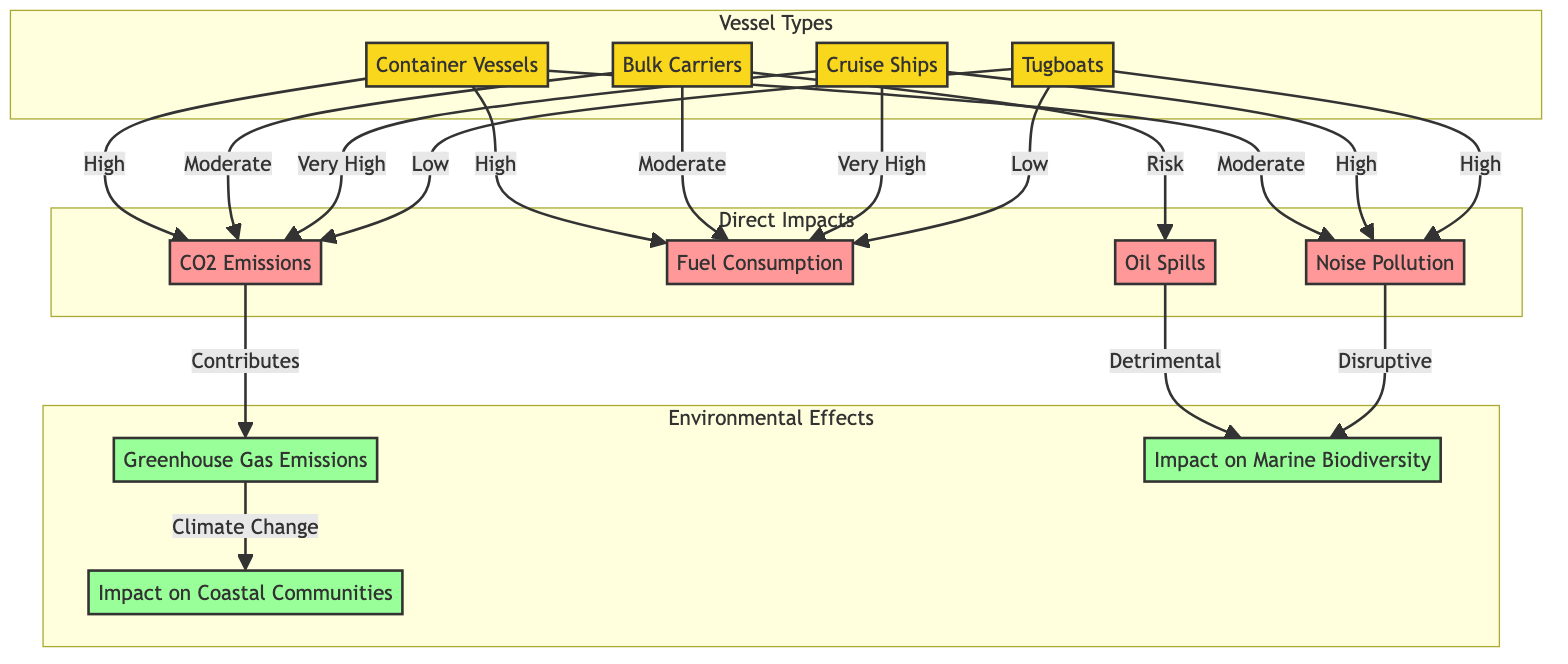What's the impact of container vessels on CO2 emissions? The diagram states that container vessels have a "High" impact on CO2 emissions, as indicated by the direct connection from the container vessels node to the CO2 emissions node with the label "High".
Answer: High How many types of vessels are shown in the diagram? The diagram includes a subgraph labeled "Vessel Types" that lists four types of vessels: container vessels, bulk carriers, cruise ships, and tugboats. Thus, the total number is four.
Answer: 4 Which vessel type has the highest level of fuel consumption? The diagram indicates that cruise ships have a "Very High" level of fuel consumption, as shown by the connection from cruise ships to the fuel consumption node with the label "Very High".
Answer: Very High What type of pollution do bulk carriers pose a risk for? The diagram shows that bulk carriers have a "Risk" associated with oil spills, as indicated by the connection from bulk carriers to the oil spills node labeled "Risk".
Answer: Oil Spills Which environmental effect is primarily affected by CO2 emissions? According to the diagram, CO2 emissions contribute to greenhouse gas emissions, as illustrated by the direct connection from the CO2 emissions node to the greenhouse gas node labeled "Contributes".
Answer: Greenhouse Gas Emissions What is the level of noise pollution caused by tugboats? The diagram states that tugboats have a "High" impact on noise pollution, as indicated by the connection from the tugboats node to the noise pollution node with the label "High".
Answer: High Which type of vessel primarily impacts marine biodiversity? The diagram indicates that both oil spills and noise pollution are detrimental and disruptive to marine biodiversity, but neither of these directly points to a specific vessel type. However, since bulk carriers pose a risk of oil spills, a strong connection can be inferred.
Answer: Bulk Carriers How does greenhouse gas emissions impact coastal communities? The diagram shows a direct connection from greenhouse gas emissions to the impact on coastal communities node with the label "Climate Change", suggesting that greenhouse gas emissions contribute adversely to community impact.
Answer: Climate Change What is the relationship between noise pollution and marine biodiversity? The diagram shows that noise pollution has a "Disruptive" effect on marine biodiversity, as indicated by the connection from the noise pollution node to the marine biodiversity node with the label "Disruptive".
Answer: Disruptive 